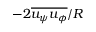Convert formula to latex. <formula><loc_0><loc_0><loc_500><loc_500>- 2 \overline { { u _ { \psi } u _ { \phi } } } / R</formula> 